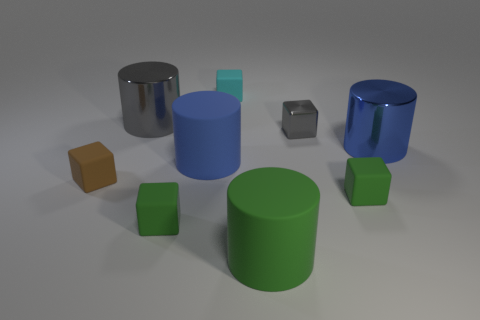What number of objects are matte things in front of the tiny cyan block or cylinders that are right of the cyan matte thing?
Provide a short and direct response. 6. Is there any other thing that has the same shape as the big green matte object?
Offer a terse response. Yes. Is the color of the rubber thing that is behind the large blue rubber thing the same as the shiny cylinder that is on the right side of the tiny metal block?
Make the answer very short. No. How many metallic objects are purple cylinders or brown cubes?
Keep it short and to the point. 0. Is there any other thing that has the same size as the gray cube?
Provide a succinct answer. Yes. There is a blue thing that is to the right of the small matte cube that is to the right of the small cyan matte block; what shape is it?
Offer a terse response. Cylinder. Do the green block to the right of the metal cube and the big cylinder behind the blue metal object have the same material?
Your response must be concise. No. How many rubber blocks are in front of the big blue cylinder that is left of the green rubber cylinder?
Ensure brevity in your answer.  3. Is the shape of the gray shiny thing in front of the gray cylinder the same as the big shiny thing that is right of the tiny gray shiny object?
Your answer should be compact. No. How big is the cylinder that is both left of the large blue metallic object and right of the tiny cyan rubber thing?
Your response must be concise. Large. 